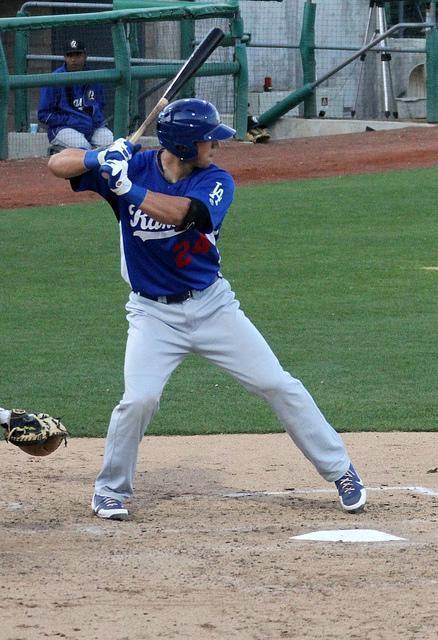How many people can be seen?
Give a very brief answer. 2. 